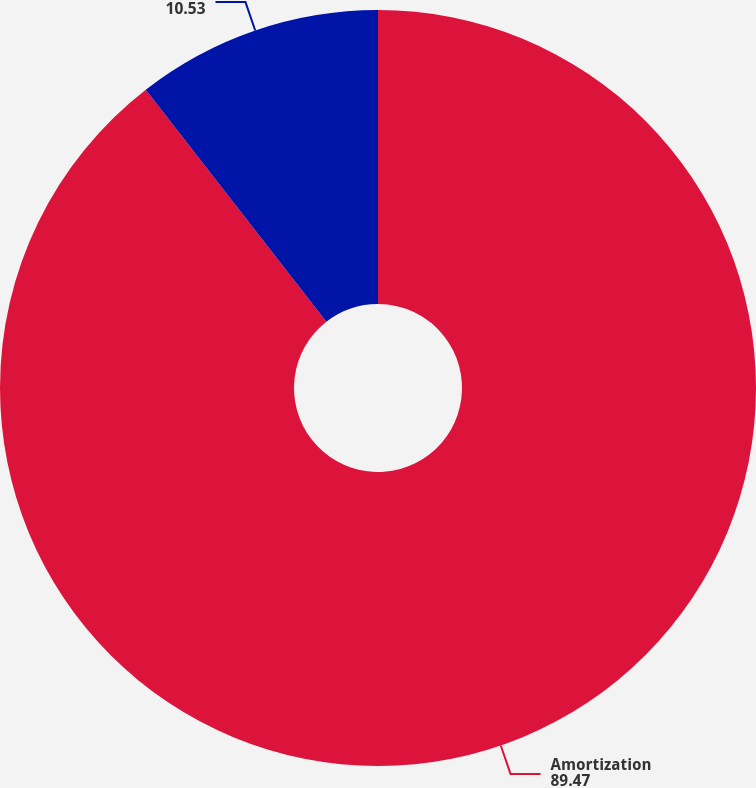<chart> <loc_0><loc_0><loc_500><loc_500><pie_chart><fcel>Amortization<fcel>Unnamed: 1<nl><fcel>89.47%<fcel>10.53%<nl></chart> 